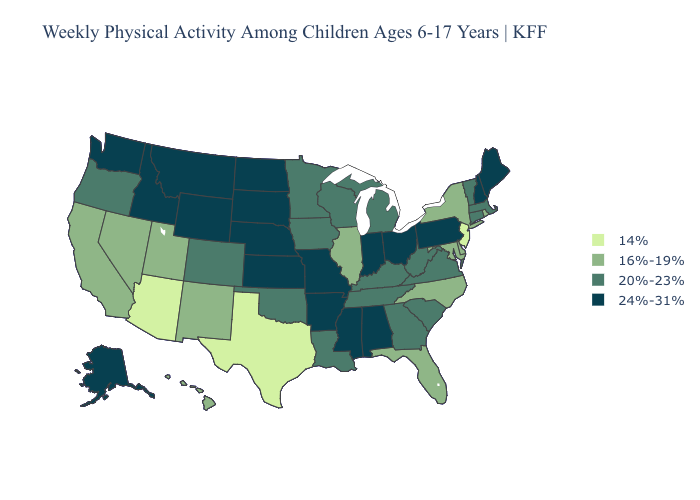Which states have the highest value in the USA?
Give a very brief answer. Alabama, Alaska, Arkansas, Idaho, Indiana, Kansas, Maine, Mississippi, Missouri, Montana, Nebraska, New Hampshire, North Dakota, Ohio, Pennsylvania, South Dakota, Washington, Wyoming. What is the highest value in the West ?
Concise answer only. 24%-31%. Does Virginia have the lowest value in the USA?
Concise answer only. No. Name the states that have a value in the range 24%-31%?
Short answer required. Alabama, Alaska, Arkansas, Idaho, Indiana, Kansas, Maine, Mississippi, Missouri, Montana, Nebraska, New Hampshire, North Dakota, Ohio, Pennsylvania, South Dakota, Washington, Wyoming. Name the states that have a value in the range 20%-23%?
Short answer required. Colorado, Connecticut, Georgia, Iowa, Kentucky, Louisiana, Massachusetts, Michigan, Minnesota, Oklahoma, Oregon, South Carolina, Tennessee, Vermont, Virginia, West Virginia, Wisconsin. Does Idaho have a higher value than Virginia?
Give a very brief answer. Yes. Among the states that border South Dakota , which have the lowest value?
Answer briefly. Iowa, Minnesota. What is the highest value in the South ?
Keep it brief. 24%-31%. Which states have the highest value in the USA?
Answer briefly. Alabama, Alaska, Arkansas, Idaho, Indiana, Kansas, Maine, Mississippi, Missouri, Montana, Nebraska, New Hampshire, North Dakota, Ohio, Pennsylvania, South Dakota, Washington, Wyoming. What is the highest value in the MidWest ?
Short answer required. 24%-31%. Does Massachusetts have a higher value than North Dakota?
Be succinct. No. Name the states that have a value in the range 14%?
Short answer required. Arizona, New Jersey, Texas. What is the lowest value in states that border Ohio?
Quick response, please. 20%-23%. Which states have the lowest value in the USA?
Give a very brief answer. Arizona, New Jersey, Texas. Does Connecticut have the same value as Colorado?
Quick response, please. Yes. 